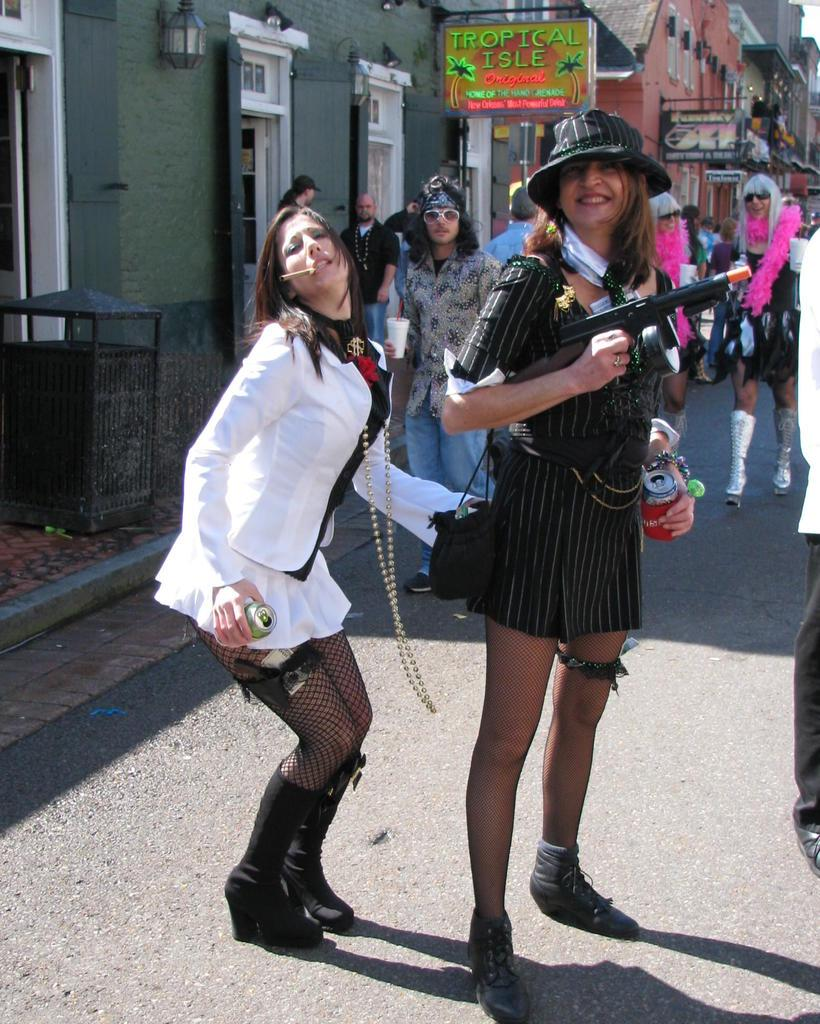How many people are in the image? There is a group of people in the image. What are the people in the image doing? Some people are standing, while others are walking on the road. What objects can be seen in the image besides the people? There are tins visible in the image. What can be seen in the background of the image? There are buildings with windows and banners present in the background. Is there any snow visible in the image? No, there is no snow present in the image. What type of power source is being used by the people in the image? There is no information about a power source in the image; it only shows people walking and standing, as well as tins and buildings in the background. 